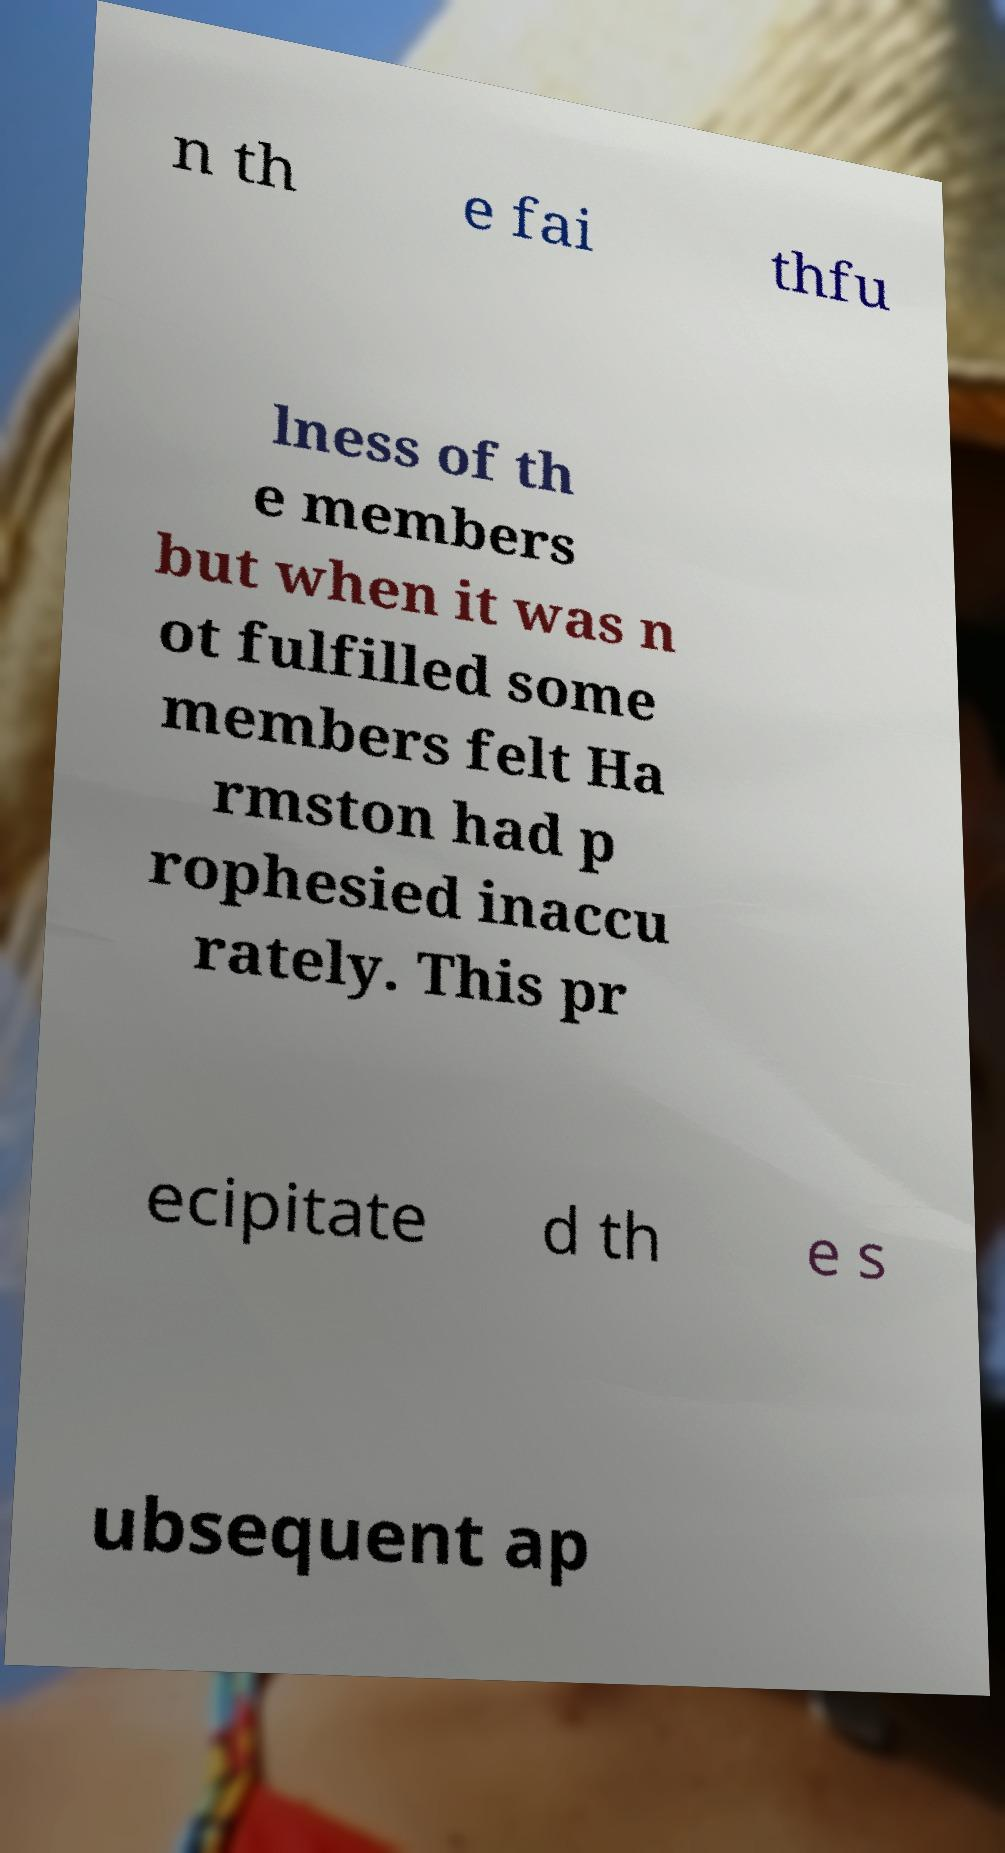Could you extract and type out the text from this image? n th e fai thfu lness of th e members but when it was n ot fulfilled some members felt Ha rmston had p rophesied inaccu rately. This pr ecipitate d th e s ubsequent ap 